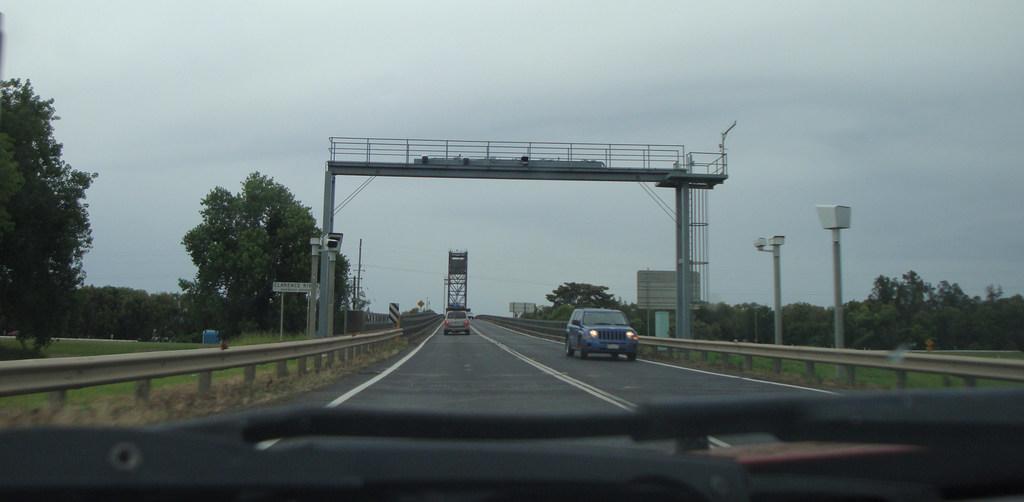Can you describe this image briefly? This picture is taken from a vehicle's windshield, I can see couple of cars on the road and It looks like a bridge and few trees on the left and right side of the picture and I can see cameras and abroad with some text and I can see a blue cloudy sky. 